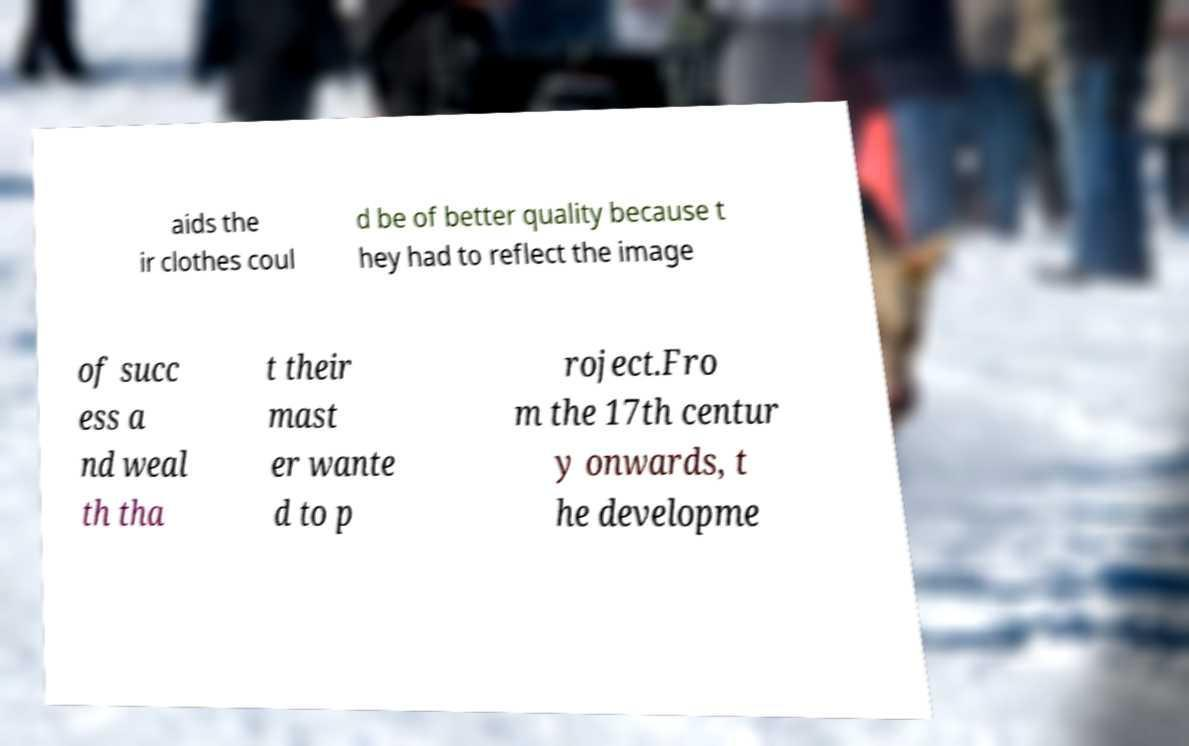What messages or text are displayed in this image? I need them in a readable, typed format. aids the ir clothes coul d be of better quality because t hey had to reflect the image of succ ess a nd weal th tha t their mast er wante d to p roject.Fro m the 17th centur y onwards, t he developme 